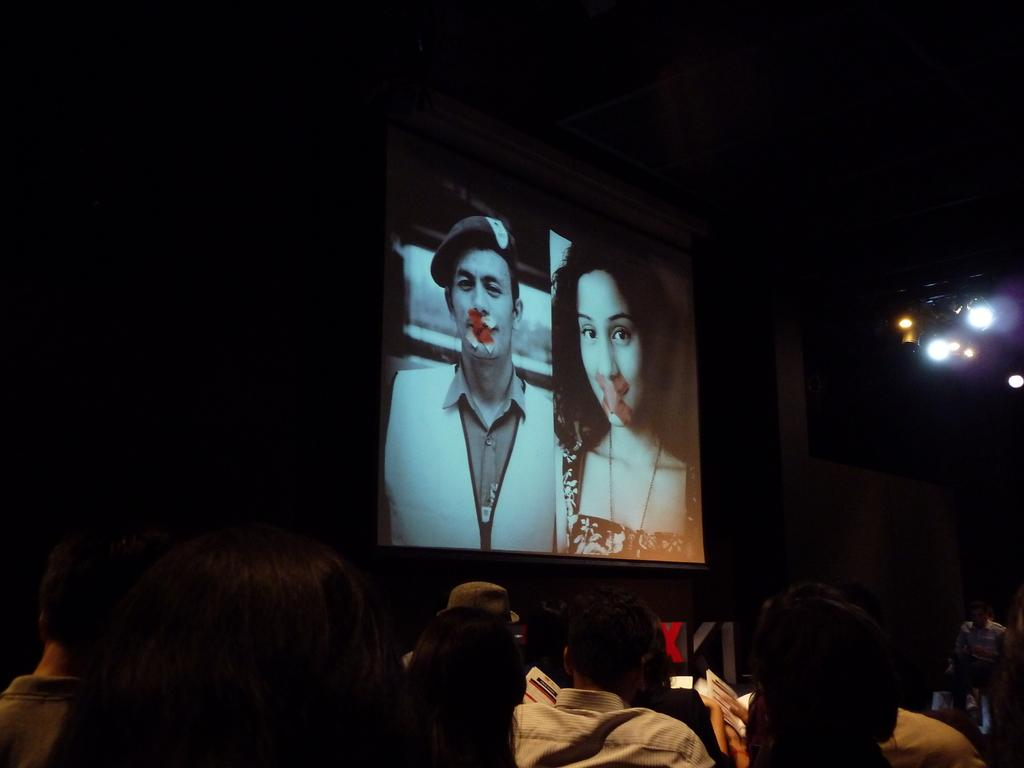How many people are in the image? There is a group of people in the image, but the exact number is not specified. What is in front of the group of people? There are lights, a screen, and other objects in front of the group of people. What can be seen on the screen in the image? The facts do not specify what is on the screen, so we cannot answer that question. What is the lighting condition in the image? The background of the image is dark, but there are lights in front of the group of people. What is the purpose of the objects in front of the group of people? The facts do not specify the purpose of the objects, so we cannot answer that question. How do the people in the image maintain balance while walking on a tightrope? There is no tightrope present in the image, so we cannot answer that question. 